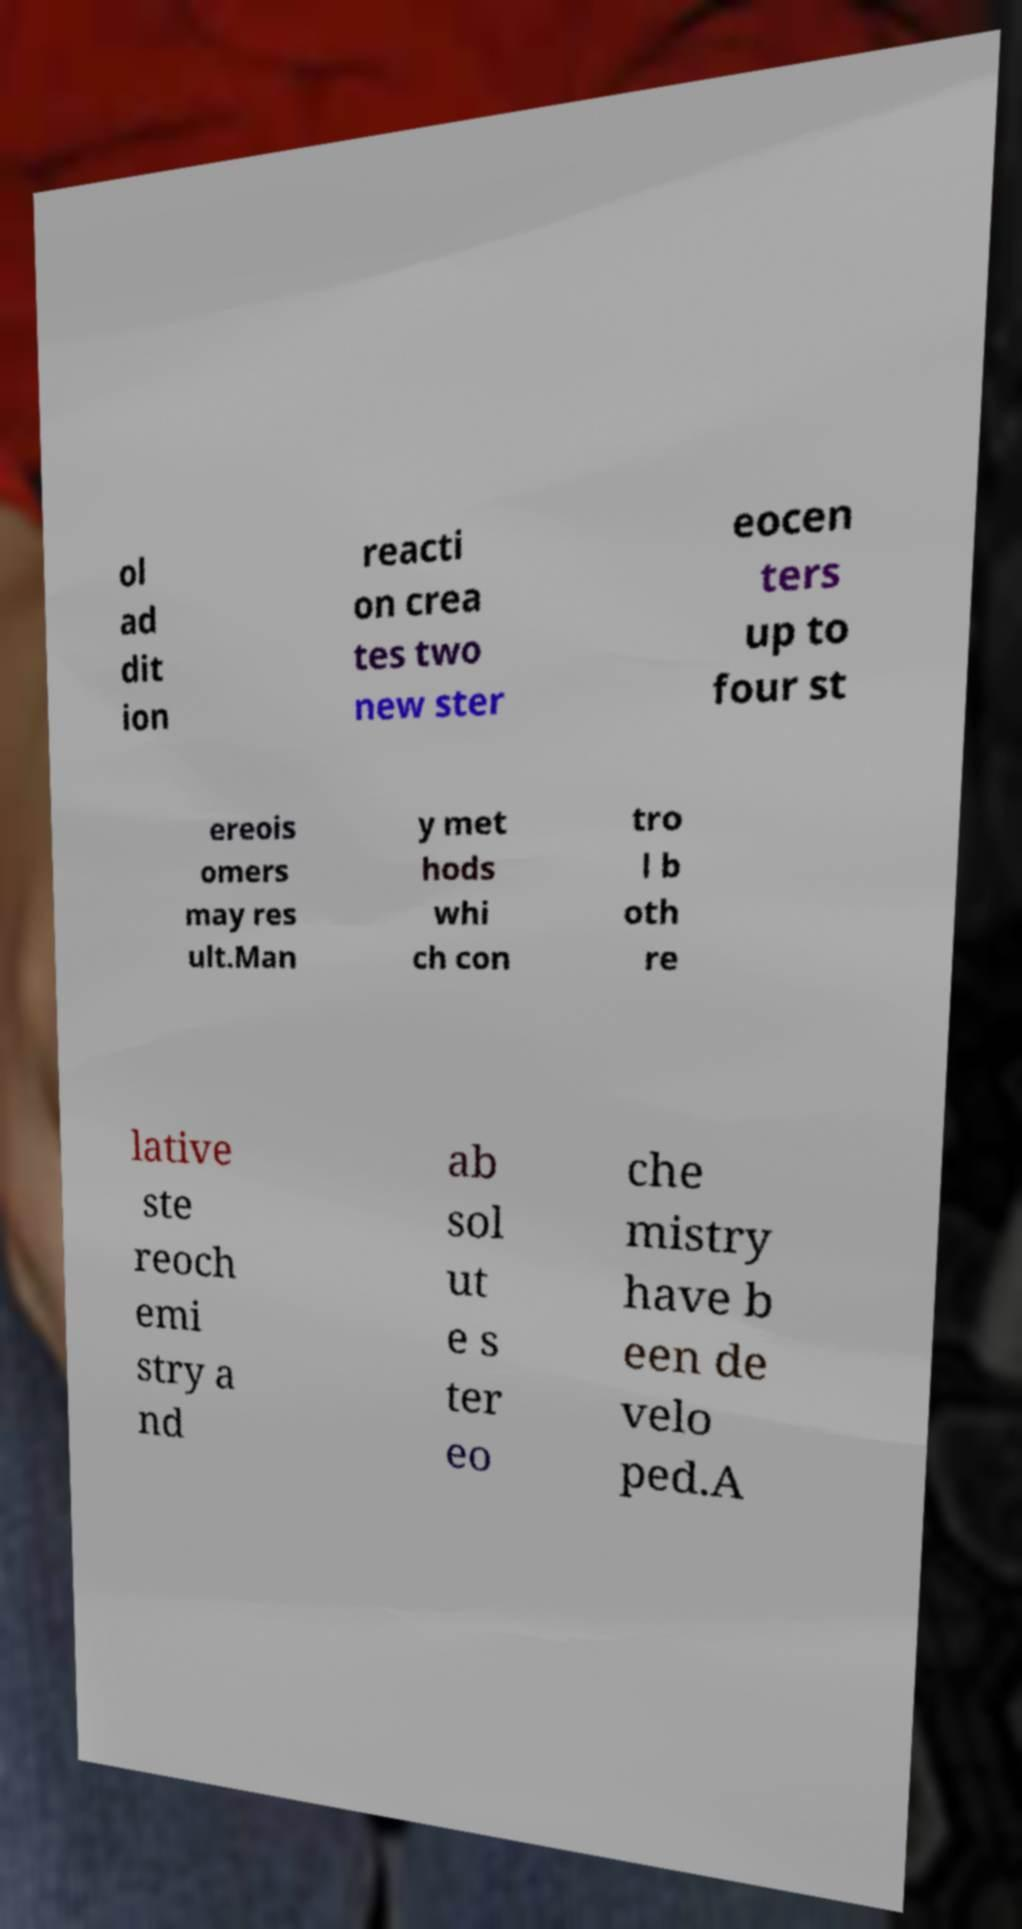I need the written content from this picture converted into text. Can you do that? ol ad dit ion reacti on crea tes two new ster eocen ters up to four st ereois omers may res ult.Man y met hods whi ch con tro l b oth re lative ste reoch emi stry a nd ab sol ut e s ter eo che mistry have b een de velo ped.A 